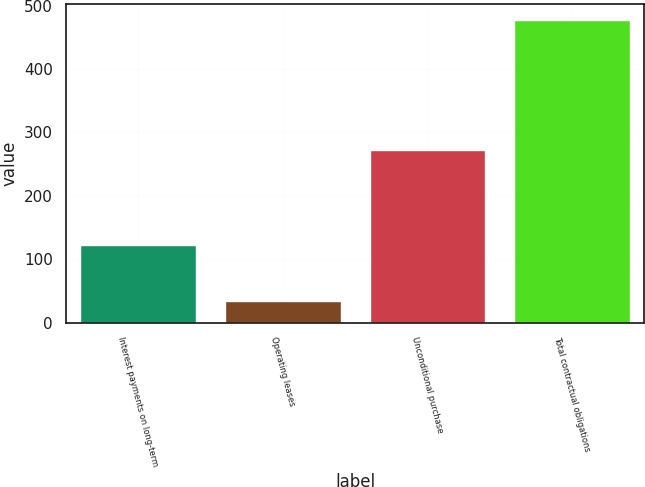Convert chart to OTSL. <chart><loc_0><loc_0><loc_500><loc_500><bar_chart><fcel>Interest payments on long-term<fcel>Operating leases<fcel>Unconditional purchase<fcel>Total contractual obligations<nl><fcel>122<fcel>34<fcel>273<fcel>478<nl></chart> 